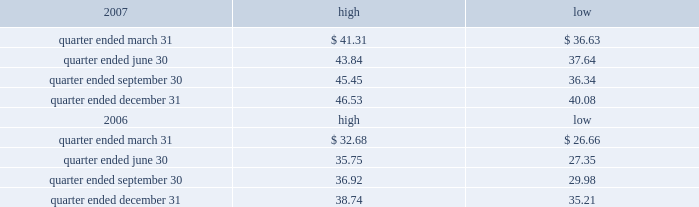Part ii item 5 .
Market for registrant 2019s common equity , related stockholder matters and issuer purchases of equity securities the table presents reported quarterly high and low per share sale prices of our class a common stock on the new york stock exchange ( 201cnyse 201d ) for the years 2007 and 2006. .
On february 29 , 2008 , the closing price of our class a common stock was $ 38.44 per share as reported on the nyse .
As of february 29 , 2008 , we had 395748826 outstanding shares of class a common stock and 528 registered holders .
Dividends we have never paid a dividend on any class of our common stock .
We anticipate that we may retain future earnings , if any , to fund the development and growth of our business .
The indentures governing our 7.50% ( 7.50 % ) senior notes due 2012 ( 201c7.50% ( 201c7.50 % ) notes 201d ) and our 7.125% ( 7.125 % ) senior notes due 2012 ( 201c7.125% ( 201c7.125 % ) notes 201d ) may prohibit us from paying dividends to our stockholders unless we satisfy certain financial covenants .
The loan agreement for our revolving credit facility and the indentures governing the terms of our 7.50% ( 7.50 % ) notes and 7.125% ( 7.125 % ) notes contain covenants that restrict our ability to pay dividends unless certain financial covenants are satisfied .
In addition , while spectrasite and its subsidiaries are classified as unrestricted subsidiaries under the indentures for our 7.50% ( 7.50 % ) notes and 7.125% ( 7.125 % ) notes , certain of spectrasite 2019s subsidiaries are subject to restrictions on the amount of cash that they can distribute to us under the loan agreement related to our securitization .
For more information about the restrictions under the loan agreement for the revolving credit facility , our notes indentures and the loan agreement related to the securitization , see item 7 of this annual report under the caption 201cmanagement 2019s discussion and analysis of financial condition and results of operations 2014liquidity and capital resources 2014factors affecting sources of liquidity 201d and note 3 to our consolidated financial statements included in this annual report. .
What is the average number of shares per registered holder as of february 29 , 2008? 
Computations: (395748826 / 528)
Answer: 749524.29167. 